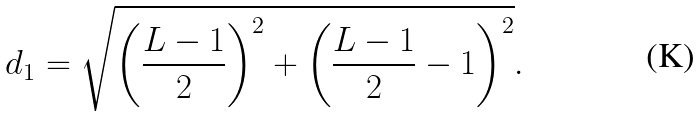<formula> <loc_0><loc_0><loc_500><loc_500>d _ { 1 } = \sqrt { \left ( \frac { L - 1 } { 2 } \right ) ^ { 2 } + \left ( \frac { L - 1 } { 2 } - 1 \right ) ^ { 2 } } .</formula> 